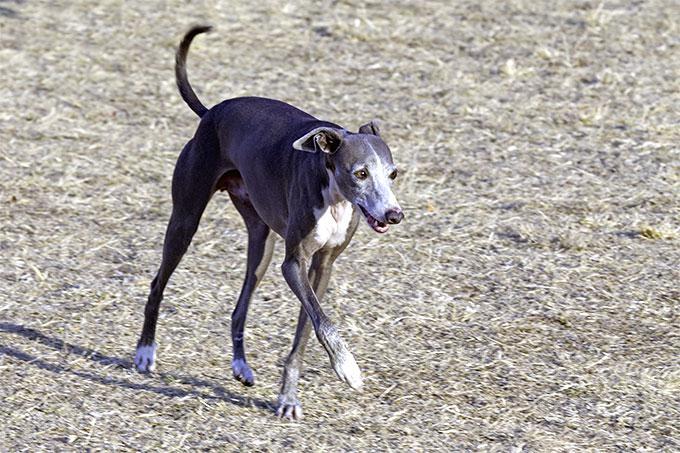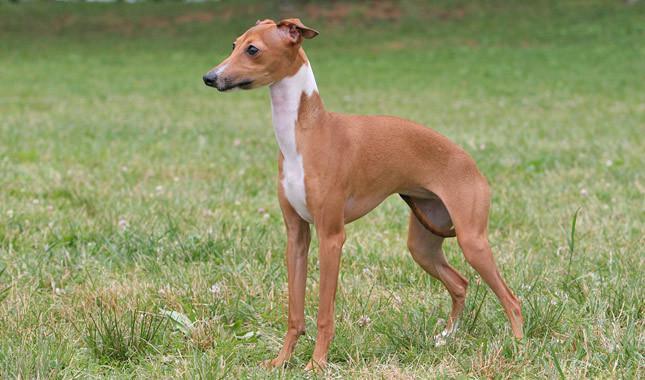The first image is the image on the left, the second image is the image on the right. Assess this claim about the two images: "All dog legs are visible and no dog is sitting or laying down.". Correct or not? Answer yes or no. Yes. 